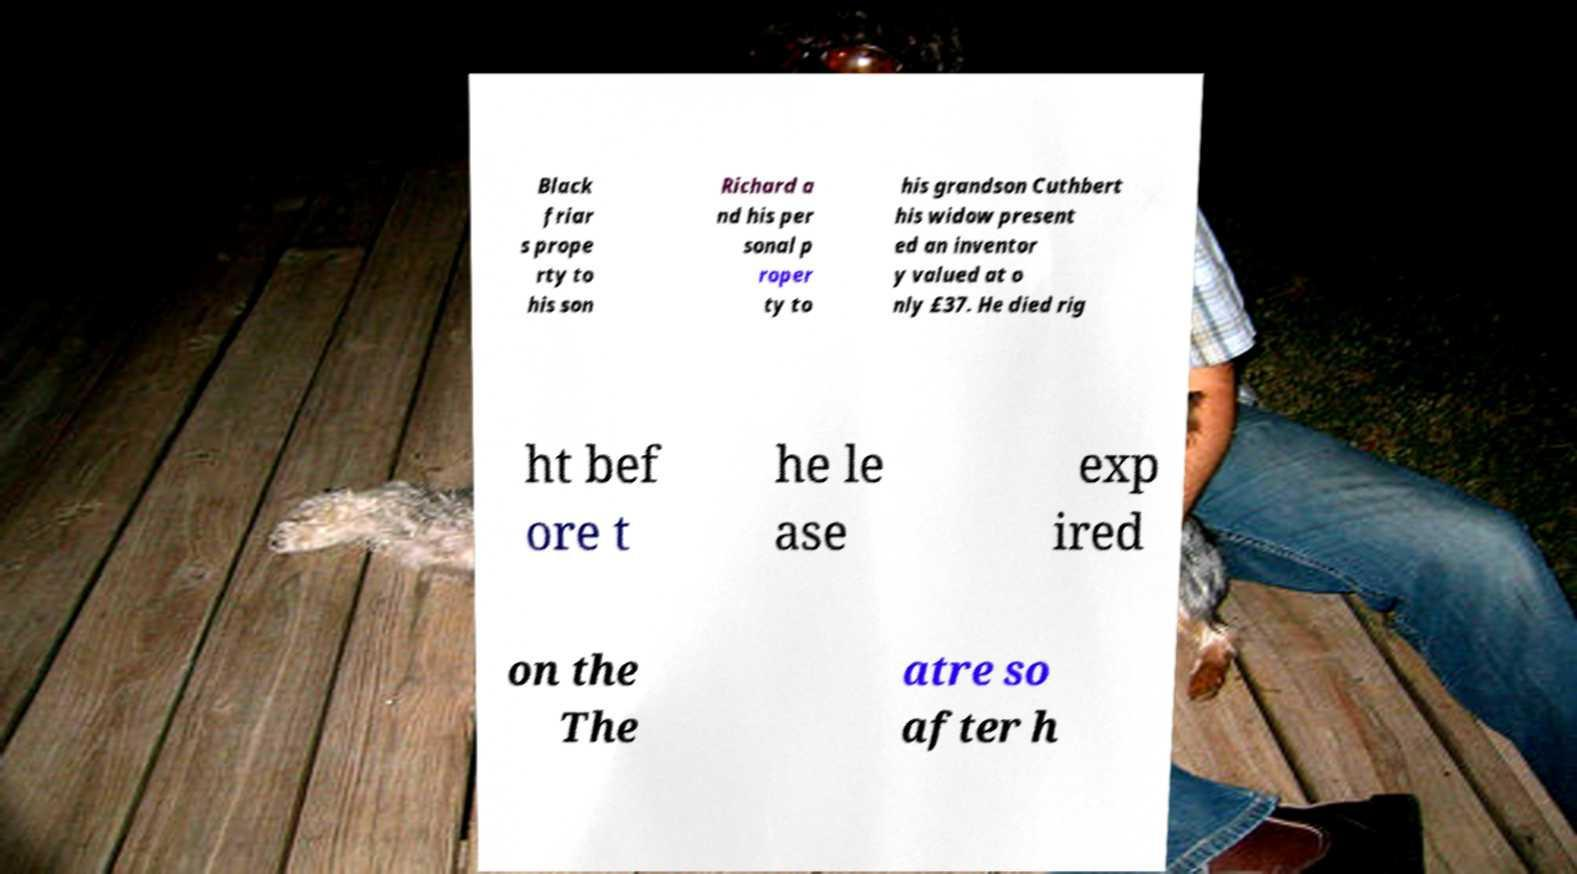Could you extract and type out the text from this image? Black friar s prope rty to his son Richard a nd his per sonal p roper ty to his grandson Cuthbert his widow present ed an inventor y valued at o nly £37. He died rig ht bef ore t he le ase exp ired on the The atre so after h 